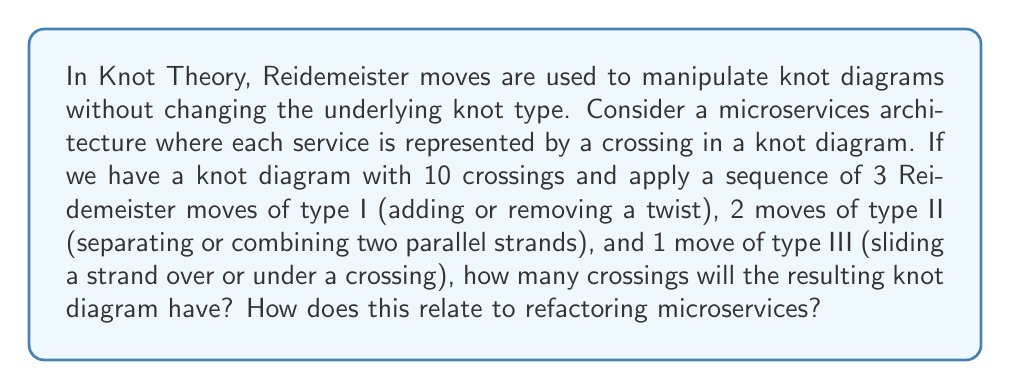What is the answer to this math problem? Let's approach this step-by-step:

1. Initial state: We start with a knot diagram representing 10 microservices (crossings).

2. Reidemeister moves:
   a. Type I (3 moves): Each move of this type either adds or removes a crossing.
      Let's assume we add 2 and remove 1: +2 - 1 = +1 net change
   b. Type II (2 moves): Each move either adds or removes 2 crossings.
      Let's assume we remove 2 crossings in each move: -4 net change
   c. Type III (1 move): This move doesn't change the number of crossings.
      Net change: 0

3. Total change in crossings:
   $$(+1) + (-4) + 0 = -3$$

4. Final number of crossings:
   $$10 + (-3) = 7$$

Relating to microservices refactoring:
- Type I moves can be seen as adding or removing a single microservice.
- Type II moves can represent merging two microservices or splitting one into two.
- Type III moves might represent reorganizing dependencies between services without changing their number.

The net reduction in crossings (from 10 to 7) suggests an overall simplification of the system architecture, which is often a goal in refactoring microservices. This process maintains the essential functionality (knot type) while reducing complexity (number of crossings).
Answer: 7 crossings; represents simplified architecture 